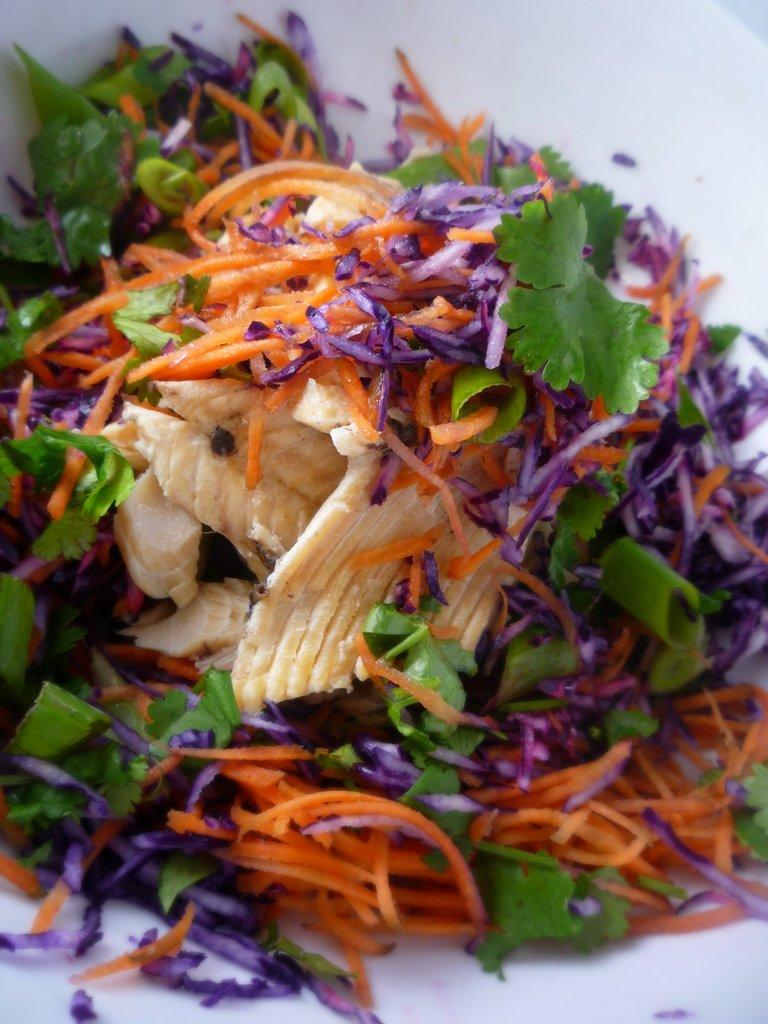What type of item is present in the image? There is an eatable item in the image. Can you describe the appearance of the eatable item? The eatable item is very colorful. What type of coil can be seen in the image? There is no coil present in the image; it only features a colorful eatable item. 